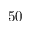Convert formula to latex. <formula><loc_0><loc_0><loc_500><loc_500>5 0</formula> 